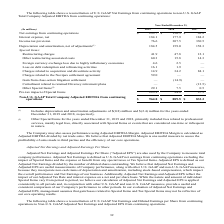According to Sealed Air Corporation's financial document, What is the definition of adjusted EBITDA? Based on the financial document, the answer is Adjusted EBITDA is defined as Earnings before Interest Expense, Taxes, Depreciation and Amortization, adjusted to exclude the impact of Special Items.. Also, How is Adjusted EBITDA Margin calculated? Adjusted EBITDA Margin is calculated as Adjusted EBITDA divided by net trade sales. The document states: "assess performance using Adjusted EBITDA Margin. Adjusted EBITDA Margin is calculated as Adjusted EBITDA divided by net trade sales. We believe that A..." Also, What is a reason for using Adjusted EBITDA Margin? Adjusted EBITDA Margin is one useful measure to assess the profitability of sales made to third parties and the efficiency of our core operations.. The document states: "EBITDA divided by net trade sales. We believe that Adjusted EBITDA Margin is one useful measure to assess the profitability of sales made to third par..." Also, can you calculate: What is the growth rate of Non-U.S. GAAP Total Company Adjusted EBITDA from continuing operations from year 2018 to year 2019? To answer this question, I need to perform calculations using the financial data. The calculation is: (964.8-889.5)/889.5, which equals 8.47 (percentage). This is based on the information: "usted EBITDA from continuing operations $ 964.8 $ 889.5 $ 833.3 pany Adjusted EBITDA from continuing operations $ 964.8 $ 889.5 $ 833.3..." The key data points involved are: 889.5, 964.8. Also, can you calculate: What is the average annual Net earnings from continuing operations for 2017-2019?  To answer this question, I need to perform calculations using the financial data. The calculation is: (293.7+150.3+62.8)/3, which equals 168.93 (in millions). This is based on the information: "ings from continuing operations $ 293.7 $ 150.3 $ 62.8 Net earnings from continuing operations $ 293.7 $ 150.3 $ 62.8 Net earnings from continuing operations $ 293.7 $ 150.3 $ 62.8..." The key data points involved are: 150.3, 293.7, 62.8. Also, can you calculate: What is the combined average annual cost of restructuring charges and other restructuring associated costs for years 2017-2019?  To answer this question, I need to perform calculations using the financial data. The calculation is: (41.9+47.8+12.1+60.3+15.8+14.3)/3, which equals 64.07 (in millions). This is based on the information: "Special Items: Restructuring charges 41.9 47.8 12.1 Other restructuring associated costs 60.3 15.8 14.3 Special Items: Restructuring charges 41.9 47.8 12.1 Other restructuring associated costs 60.3 15..." The key data points involved are: 12.1, 14.3, 15.8. 